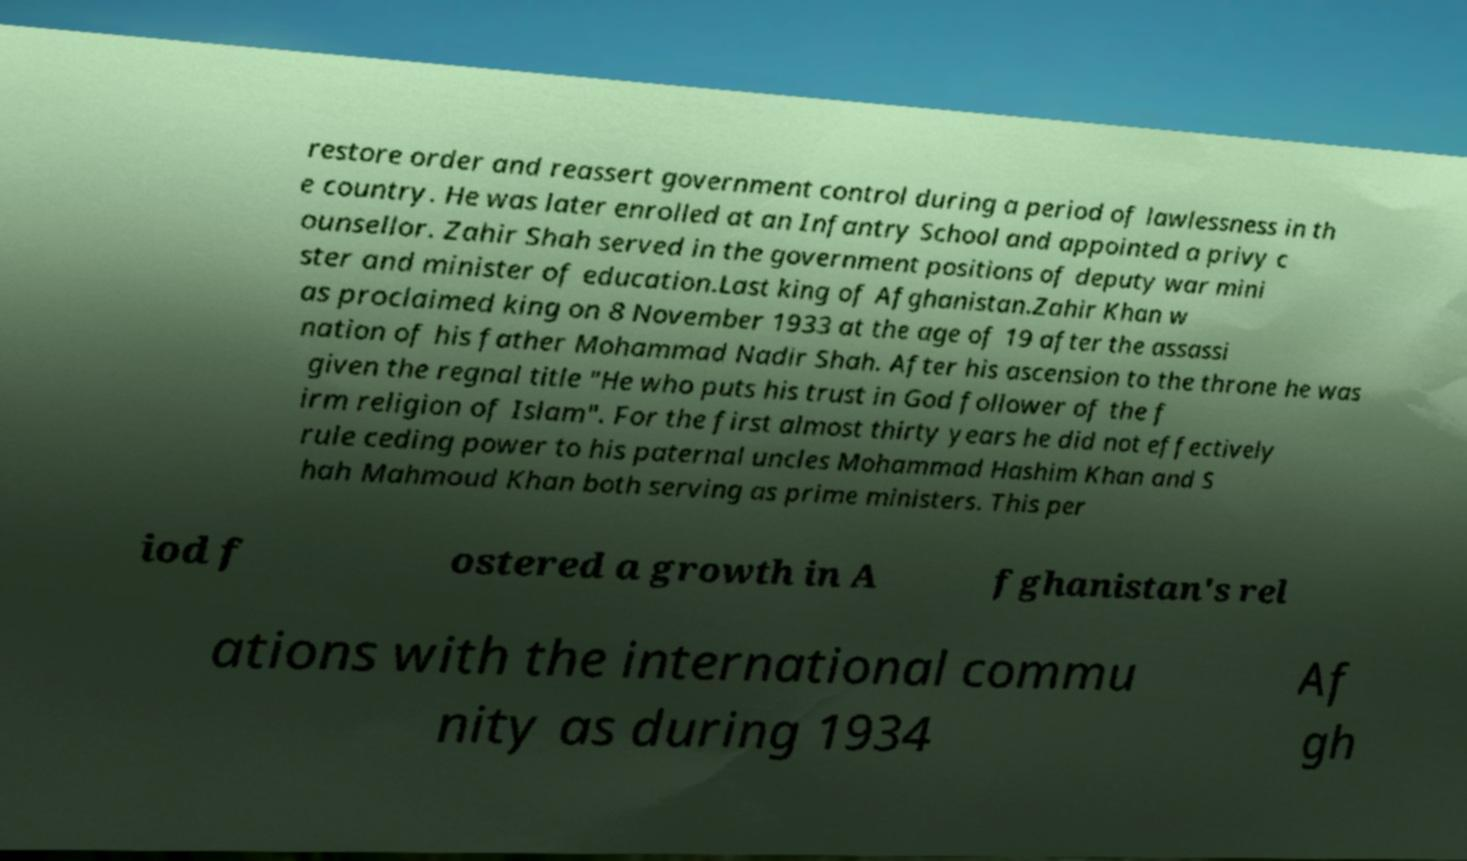Can you accurately transcribe the text from the provided image for me? restore order and reassert government control during a period of lawlessness in th e country. He was later enrolled at an Infantry School and appointed a privy c ounsellor. Zahir Shah served in the government positions of deputy war mini ster and minister of education.Last king of Afghanistan.Zahir Khan w as proclaimed king on 8 November 1933 at the age of 19 after the assassi nation of his father Mohammad Nadir Shah. After his ascension to the throne he was given the regnal title "He who puts his trust in God follower of the f irm religion of Islam". For the first almost thirty years he did not effectively rule ceding power to his paternal uncles Mohammad Hashim Khan and S hah Mahmoud Khan both serving as prime ministers. This per iod f ostered a growth in A fghanistan's rel ations with the international commu nity as during 1934 Af gh 